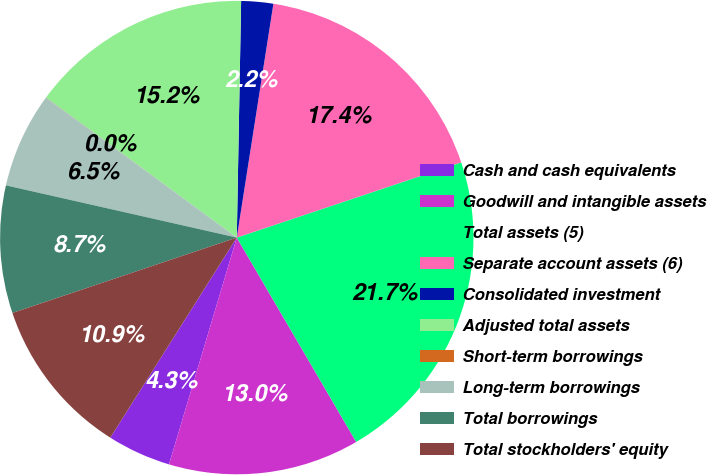Convert chart to OTSL. <chart><loc_0><loc_0><loc_500><loc_500><pie_chart><fcel>Cash and cash equivalents<fcel>Goodwill and intangible assets<fcel>Total assets (5)<fcel>Separate account assets (6)<fcel>Consolidated investment<fcel>Adjusted total assets<fcel>Short-term borrowings<fcel>Long-term borrowings<fcel>Total borrowings<fcel>Total stockholders' equity<nl><fcel>4.35%<fcel>13.04%<fcel>21.73%<fcel>17.38%<fcel>2.18%<fcel>15.21%<fcel>0.01%<fcel>6.53%<fcel>8.7%<fcel>10.87%<nl></chart> 